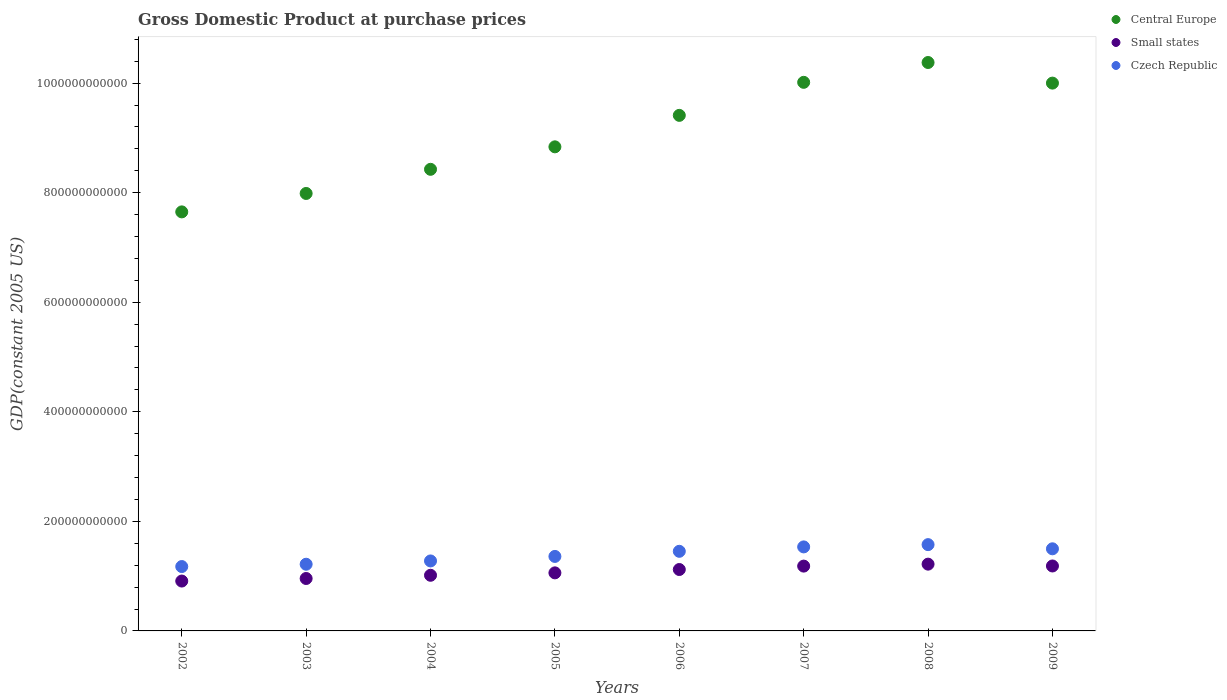How many different coloured dotlines are there?
Keep it short and to the point. 3. What is the GDP at purchase prices in Central Europe in 2002?
Your answer should be very brief. 7.65e+11. Across all years, what is the maximum GDP at purchase prices in Small states?
Offer a terse response. 1.22e+11. Across all years, what is the minimum GDP at purchase prices in Small states?
Provide a succinct answer. 9.10e+1. In which year was the GDP at purchase prices in Czech Republic maximum?
Keep it short and to the point. 2008. What is the total GDP at purchase prices in Small states in the graph?
Your response must be concise. 8.65e+11. What is the difference between the GDP at purchase prices in Small states in 2003 and that in 2006?
Provide a short and direct response. -1.64e+1. What is the difference between the GDP at purchase prices in Central Europe in 2007 and the GDP at purchase prices in Small states in 2008?
Offer a very short reply. 8.80e+11. What is the average GDP at purchase prices in Central Europe per year?
Your answer should be compact. 9.09e+11. In the year 2006, what is the difference between the GDP at purchase prices in Small states and GDP at purchase prices in Central Europe?
Ensure brevity in your answer.  -8.29e+11. What is the ratio of the GDP at purchase prices in Central Europe in 2002 to that in 2006?
Offer a terse response. 0.81. What is the difference between the highest and the second highest GDP at purchase prices in Small states?
Provide a succinct answer. 3.35e+09. What is the difference between the highest and the lowest GDP at purchase prices in Central Europe?
Offer a very short reply. 2.73e+11. In how many years, is the GDP at purchase prices in Small states greater than the average GDP at purchase prices in Small states taken over all years?
Provide a succinct answer. 4. Is the GDP at purchase prices in Small states strictly less than the GDP at purchase prices in Central Europe over the years?
Your response must be concise. Yes. How many years are there in the graph?
Provide a succinct answer. 8. What is the difference between two consecutive major ticks on the Y-axis?
Ensure brevity in your answer.  2.00e+11. Are the values on the major ticks of Y-axis written in scientific E-notation?
Make the answer very short. No. Where does the legend appear in the graph?
Keep it short and to the point. Top right. How many legend labels are there?
Give a very brief answer. 3. What is the title of the graph?
Provide a succinct answer. Gross Domestic Product at purchase prices. Does "Costa Rica" appear as one of the legend labels in the graph?
Your answer should be very brief. No. What is the label or title of the Y-axis?
Your response must be concise. GDP(constant 2005 US). What is the GDP(constant 2005 US) of Central Europe in 2002?
Your answer should be very brief. 7.65e+11. What is the GDP(constant 2005 US) of Small states in 2002?
Provide a short and direct response. 9.10e+1. What is the GDP(constant 2005 US) of Czech Republic in 2002?
Your answer should be compact. 1.18e+11. What is the GDP(constant 2005 US) in Central Europe in 2003?
Your answer should be very brief. 7.99e+11. What is the GDP(constant 2005 US) of Small states in 2003?
Ensure brevity in your answer.  9.57e+1. What is the GDP(constant 2005 US) in Czech Republic in 2003?
Your answer should be compact. 1.22e+11. What is the GDP(constant 2005 US) of Central Europe in 2004?
Give a very brief answer. 8.43e+11. What is the GDP(constant 2005 US) of Small states in 2004?
Make the answer very short. 1.02e+11. What is the GDP(constant 2005 US) in Czech Republic in 2004?
Your answer should be very brief. 1.28e+11. What is the GDP(constant 2005 US) in Central Europe in 2005?
Provide a short and direct response. 8.84e+11. What is the GDP(constant 2005 US) of Small states in 2005?
Keep it short and to the point. 1.06e+11. What is the GDP(constant 2005 US) in Czech Republic in 2005?
Keep it short and to the point. 1.36e+11. What is the GDP(constant 2005 US) of Central Europe in 2006?
Give a very brief answer. 9.41e+11. What is the GDP(constant 2005 US) of Small states in 2006?
Make the answer very short. 1.12e+11. What is the GDP(constant 2005 US) in Czech Republic in 2006?
Your answer should be compact. 1.45e+11. What is the GDP(constant 2005 US) of Central Europe in 2007?
Your answer should be very brief. 1.00e+12. What is the GDP(constant 2005 US) of Small states in 2007?
Offer a terse response. 1.18e+11. What is the GDP(constant 2005 US) in Czech Republic in 2007?
Give a very brief answer. 1.53e+11. What is the GDP(constant 2005 US) in Central Europe in 2008?
Provide a succinct answer. 1.04e+12. What is the GDP(constant 2005 US) of Small states in 2008?
Provide a succinct answer. 1.22e+11. What is the GDP(constant 2005 US) of Czech Republic in 2008?
Give a very brief answer. 1.58e+11. What is the GDP(constant 2005 US) in Central Europe in 2009?
Make the answer very short. 1.00e+12. What is the GDP(constant 2005 US) in Small states in 2009?
Your response must be concise. 1.19e+11. What is the GDP(constant 2005 US) of Czech Republic in 2009?
Keep it short and to the point. 1.50e+11. Across all years, what is the maximum GDP(constant 2005 US) in Central Europe?
Make the answer very short. 1.04e+12. Across all years, what is the maximum GDP(constant 2005 US) in Small states?
Give a very brief answer. 1.22e+11. Across all years, what is the maximum GDP(constant 2005 US) of Czech Republic?
Offer a terse response. 1.58e+11. Across all years, what is the minimum GDP(constant 2005 US) in Central Europe?
Give a very brief answer. 7.65e+11. Across all years, what is the minimum GDP(constant 2005 US) of Small states?
Provide a short and direct response. 9.10e+1. Across all years, what is the minimum GDP(constant 2005 US) of Czech Republic?
Provide a succinct answer. 1.18e+11. What is the total GDP(constant 2005 US) in Central Europe in the graph?
Your answer should be compact. 7.27e+12. What is the total GDP(constant 2005 US) in Small states in the graph?
Offer a very short reply. 8.65e+11. What is the total GDP(constant 2005 US) of Czech Republic in the graph?
Your response must be concise. 1.11e+12. What is the difference between the GDP(constant 2005 US) of Central Europe in 2002 and that in 2003?
Make the answer very short. -3.36e+1. What is the difference between the GDP(constant 2005 US) of Small states in 2002 and that in 2003?
Ensure brevity in your answer.  -4.67e+09. What is the difference between the GDP(constant 2005 US) in Czech Republic in 2002 and that in 2003?
Offer a very short reply. -4.23e+09. What is the difference between the GDP(constant 2005 US) in Central Europe in 2002 and that in 2004?
Ensure brevity in your answer.  -7.77e+1. What is the difference between the GDP(constant 2005 US) in Small states in 2002 and that in 2004?
Give a very brief answer. -1.05e+1. What is the difference between the GDP(constant 2005 US) of Czech Republic in 2002 and that in 2004?
Provide a short and direct response. -1.03e+1. What is the difference between the GDP(constant 2005 US) of Central Europe in 2002 and that in 2005?
Ensure brevity in your answer.  -1.19e+11. What is the difference between the GDP(constant 2005 US) of Small states in 2002 and that in 2005?
Your answer should be very brief. -1.49e+1. What is the difference between the GDP(constant 2005 US) of Czech Republic in 2002 and that in 2005?
Keep it short and to the point. -1.85e+1. What is the difference between the GDP(constant 2005 US) in Central Europe in 2002 and that in 2006?
Give a very brief answer. -1.76e+11. What is the difference between the GDP(constant 2005 US) in Small states in 2002 and that in 2006?
Provide a succinct answer. -2.11e+1. What is the difference between the GDP(constant 2005 US) in Czech Republic in 2002 and that in 2006?
Offer a terse response. -2.78e+1. What is the difference between the GDP(constant 2005 US) in Central Europe in 2002 and that in 2007?
Provide a succinct answer. -2.37e+11. What is the difference between the GDP(constant 2005 US) in Small states in 2002 and that in 2007?
Keep it short and to the point. -2.73e+1. What is the difference between the GDP(constant 2005 US) of Czech Republic in 2002 and that in 2007?
Your response must be concise. -3.59e+1. What is the difference between the GDP(constant 2005 US) of Central Europe in 2002 and that in 2008?
Your answer should be very brief. -2.73e+11. What is the difference between the GDP(constant 2005 US) of Small states in 2002 and that in 2008?
Provide a succinct answer. -3.09e+1. What is the difference between the GDP(constant 2005 US) of Czech Republic in 2002 and that in 2008?
Give a very brief answer. -4.00e+1. What is the difference between the GDP(constant 2005 US) in Central Europe in 2002 and that in 2009?
Give a very brief answer. -2.35e+11. What is the difference between the GDP(constant 2005 US) of Small states in 2002 and that in 2009?
Make the answer very short. -2.75e+1. What is the difference between the GDP(constant 2005 US) of Czech Republic in 2002 and that in 2009?
Keep it short and to the point. -3.24e+1. What is the difference between the GDP(constant 2005 US) in Central Europe in 2003 and that in 2004?
Keep it short and to the point. -4.41e+1. What is the difference between the GDP(constant 2005 US) of Small states in 2003 and that in 2004?
Your answer should be compact. -5.88e+09. What is the difference between the GDP(constant 2005 US) in Czech Republic in 2003 and that in 2004?
Offer a very short reply. -6.02e+09. What is the difference between the GDP(constant 2005 US) in Central Europe in 2003 and that in 2005?
Your answer should be compact. -8.51e+1. What is the difference between the GDP(constant 2005 US) of Small states in 2003 and that in 2005?
Keep it short and to the point. -1.03e+1. What is the difference between the GDP(constant 2005 US) of Czech Republic in 2003 and that in 2005?
Make the answer very short. -1.43e+1. What is the difference between the GDP(constant 2005 US) of Central Europe in 2003 and that in 2006?
Ensure brevity in your answer.  -1.43e+11. What is the difference between the GDP(constant 2005 US) in Small states in 2003 and that in 2006?
Your answer should be very brief. -1.64e+1. What is the difference between the GDP(constant 2005 US) in Czech Republic in 2003 and that in 2006?
Make the answer very short. -2.36e+1. What is the difference between the GDP(constant 2005 US) of Central Europe in 2003 and that in 2007?
Offer a terse response. -2.03e+11. What is the difference between the GDP(constant 2005 US) in Small states in 2003 and that in 2007?
Provide a succinct answer. -2.26e+1. What is the difference between the GDP(constant 2005 US) of Czech Republic in 2003 and that in 2007?
Offer a terse response. -3.16e+1. What is the difference between the GDP(constant 2005 US) in Central Europe in 2003 and that in 2008?
Give a very brief answer. -2.39e+11. What is the difference between the GDP(constant 2005 US) of Small states in 2003 and that in 2008?
Keep it short and to the point. -2.62e+1. What is the difference between the GDP(constant 2005 US) of Czech Republic in 2003 and that in 2008?
Provide a succinct answer. -3.58e+1. What is the difference between the GDP(constant 2005 US) in Central Europe in 2003 and that in 2009?
Provide a succinct answer. -2.01e+11. What is the difference between the GDP(constant 2005 US) in Small states in 2003 and that in 2009?
Provide a short and direct response. -2.28e+1. What is the difference between the GDP(constant 2005 US) of Czech Republic in 2003 and that in 2009?
Give a very brief answer. -2.82e+1. What is the difference between the GDP(constant 2005 US) of Central Europe in 2004 and that in 2005?
Keep it short and to the point. -4.10e+1. What is the difference between the GDP(constant 2005 US) in Small states in 2004 and that in 2005?
Make the answer very short. -4.40e+09. What is the difference between the GDP(constant 2005 US) of Czech Republic in 2004 and that in 2005?
Give a very brief answer. -8.23e+09. What is the difference between the GDP(constant 2005 US) in Central Europe in 2004 and that in 2006?
Provide a short and direct response. -9.85e+1. What is the difference between the GDP(constant 2005 US) in Small states in 2004 and that in 2006?
Your answer should be compact. -1.05e+1. What is the difference between the GDP(constant 2005 US) of Czech Republic in 2004 and that in 2006?
Keep it short and to the point. -1.76e+1. What is the difference between the GDP(constant 2005 US) of Central Europe in 2004 and that in 2007?
Your answer should be compact. -1.59e+11. What is the difference between the GDP(constant 2005 US) in Small states in 2004 and that in 2007?
Your answer should be compact. -1.67e+1. What is the difference between the GDP(constant 2005 US) of Czech Republic in 2004 and that in 2007?
Your answer should be compact. -2.56e+1. What is the difference between the GDP(constant 2005 US) of Central Europe in 2004 and that in 2008?
Your response must be concise. -1.95e+11. What is the difference between the GDP(constant 2005 US) of Small states in 2004 and that in 2008?
Your answer should be compact. -2.03e+1. What is the difference between the GDP(constant 2005 US) of Czech Republic in 2004 and that in 2008?
Offer a very short reply. -2.98e+1. What is the difference between the GDP(constant 2005 US) in Central Europe in 2004 and that in 2009?
Make the answer very short. -1.57e+11. What is the difference between the GDP(constant 2005 US) of Small states in 2004 and that in 2009?
Ensure brevity in your answer.  -1.70e+1. What is the difference between the GDP(constant 2005 US) of Czech Republic in 2004 and that in 2009?
Provide a short and direct response. -2.21e+1. What is the difference between the GDP(constant 2005 US) in Central Europe in 2005 and that in 2006?
Ensure brevity in your answer.  -5.74e+1. What is the difference between the GDP(constant 2005 US) in Small states in 2005 and that in 2006?
Your answer should be very brief. -6.12e+09. What is the difference between the GDP(constant 2005 US) in Czech Republic in 2005 and that in 2006?
Make the answer very short. -9.35e+09. What is the difference between the GDP(constant 2005 US) in Central Europe in 2005 and that in 2007?
Provide a succinct answer. -1.18e+11. What is the difference between the GDP(constant 2005 US) of Small states in 2005 and that in 2007?
Ensure brevity in your answer.  -1.23e+1. What is the difference between the GDP(constant 2005 US) of Czech Republic in 2005 and that in 2007?
Offer a terse response. -1.74e+1. What is the difference between the GDP(constant 2005 US) in Central Europe in 2005 and that in 2008?
Give a very brief answer. -1.54e+11. What is the difference between the GDP(constant 2005 US) in Small states in 2005 and that in 2008?
Your response must be concise. -1.59e+1. What is the difference between the GDP(constant 2005 US) of Czech Republic in 2005 and that in 2008?
Offer a terse response. -2.15e+1. What is the difference between the GDP(constant 2005 US) in Central Europe in 2005 and that in 2009?
Provide a short and direct response. -1.16e+11. What is the difference between the GDP(constant 2005 US) of Small states in 2005 and that in 2009?
Provide a succinct answer. -1.26e+1. What is the difference between the GDP(constant 2005 US) in Czech Republic in 2005 and that in 2009?
Your answer should be very brief. -1.39e+1. What is the difference between the GDP(constant 2005 US) in Central Europe in 2006 and that in 2007?
Offer a terse response. -6.03e+1. What is the difference between the GDP(constant 2005 US) in Small states in 2006 and that in 2007?
Your answer should be compact. -6.22e+09. What is the difference between the GDP(constant 2005 US) of Czech Republic in 2006 and that in 2007?
Make the answer very short. -8.04e+09. What is the difference between the GDP(constant 2005 US) of Central Europe in 2006 and that in 2008?
Offer a very short reply. -9.65e+1. What is the difference between the GDP(constant 2005 US) of Small states in 2006 and that in 2008?
Provide a short and direct response. -9.80e+09. What is the difference between the GDP(constant 2005 US) of Czech Republic in 2006 and that in 2008?
Your answer should be compact. -1.22e+1. What is the difference between the GDP(constant 2005 US) of Central Europe in 2006 and that in 2009?
Offer a terse response. -5.89e+1. What is the difference between the GDP(constant 2005 US) in Small states in 2006 and that in 2009?
Offer a terse response. -6.45e+09. What is the difference between the GDP(constant 2005 US) in Czech Republic in 2006 and that in 2009?
Make the answer very short. -4.57e+09. What is the difference between the GDP(constant 2005 US) in Central Europe in 2007 and that in 2008?
Offer a very short reply. -3.62e+1. What is the difference between the GDP(constant 2005 US) of Small states in 2007 and that in 2008?
Keep it short and to the point. -3.59e+09. What is the difference between the GDP(constant 2005 US) in Czech Republic in 2007 and that in 2008?
Keep it short and to the point. -4.16e+09. What is the difference between the GDP(constant 2005 US) of Central Europe in 2007 and that in 2009?
Ensure brevity in your answer.  1.42e+09. What is the difference between the GDP(constant 2005 US) of Small states in 2007 and that in 2009?
Ensure brevity in your answer.  -2.36e+08. What is the difference between the GDP(constant 2005 US) in Czech Republic in 2007 and that in 2009?
Your response must be concise. 3.47e+09. What is the difference between the GDP(constant 2005 US) of Central Europe in 2008 and that in 2009?
Your response must be concise. 3.76e+1. What is the difference between the GDP(constant 2005 US) in Small states in 2008 and that in 2009?
Keep it short and to the point. 3.35e+09. What is the difference between the GDP(constant 2005 US) of Czech Republic in 2008 and that in 2009?
Your answer should be compact. 7.63e+09. What is the difference between the GDP(constant 2005 US) in Central Europe in 2002 and the GDP(constant 2005 US) in Small states in 2003?
Make the answer very short. 6.69e+11. What is the difference between the GDP(constant 2005 US) of Central Europe in 2002 and the GDP(constant 2005 US) of Czech Republic in 2003?
Provide a succinct answer. 6.43e+11. What is the difference between the GDP(constant 2005 US) in Small states in 2002 and the GDP(constant 2005 US) in Czech Republic in 2003?
Keep it short and to the point. -3.07e+1. What is the difference between the GDP(constant 2005 US) of Central Europe in 2002 and the GDP(constant 2005 US) of Small states in 2004?
Give a very brief answer. 6.63e+11. What is the difference between the GDP(constant 2005 US) of Central Europe in 2002 and the GDP(constant 2005 US) of Czech Republic in 2004?
Provide a short and direct response. 6.37e+11. What is the difference between the GDP(constant 2005 US) in Small states in 2002 and the GDP(constant 2005 US) in Czech Republic in 2004?
Keep it short and to the point. -3.67e+1. What is the difference between the GDP(constant 2005 US) of Central Europe in 2002 and the GDP(constant 2005 US) of Small states in 2005?
Your answer should be very brief. 6.59e+11. What is the difference between the GDP(constant 2005 US) of Central Europe in 2002 and the GDP(constant 2005 US) of Czech Republic in 2005?
Ensure brevity in your answer.  6.29e+11. What is the difference between the GDP(constant 2005 US) in Small states in 2002 and the GDP(constant 2005 US) in Czech Republic in 2005?
Provide a short and direct response. -4.50e+1. What is the difference between the GDP(constant 2005 US) of Central Europe in 2002 and the GDP(constant 2005 US) of Small states in 2006?
Your answer should be compact. 6.53e+11. What is the difference between the GDP(constant 2005 US) in Central Europe in 2002 and the GDP(constant 2005 US) in Czech Republic in 2006?
Your answer should be compact. 6.20e+11. What is the difference between the GDP(constant 2005 US) in Small states in 2002 and the GDP(constant 2005 US) in Czech Republic in 2006?
Keep it short and to the point. -5.43e+1. What is the difference between the GDP(constant 2005 US) of Central Europe in 2002 and the GDP(constant 2005 US) of Small states in 2007?
Ensure brevity in your answer.  6.47e+11. What is the difference between the GDP(constant 2005 US) in Central Europe in 2002 and the GDP(constant 2005 US) in Czech Republic in 2007?
Ensure brevity in your answer.  6.12e+11. What is the difference between the GDP(constant 2005 US) of Small states in 2002 and the GDP(constant 2005 US) of Czech Republic in 2007?
Offer a terse response. -6.23e+1. What is the difference between the GDP(constant 2005 US) of Central Europe in 2002 and the GDP(constant 2005 US) of Small states in 2008?
Keep it short and to the point. 6.43e+11. What is the difference between the GDP(constant 2005 US) in Central Europe in 2002 and the GDP(constant 2005 US) in Czech Republic in 2008?
Give a very brief answer. 6.07e+11. What is the difference between the GDP(constant 2005 US) of Small states in 2002 and the GDP(constant 2005 US) of Czech Republic in 2008?
Provide a succinct answer. -6.65e+1. What is the difference between the GDP(constant 2005 US) in Central Europe in 2002 and the GDP(constant 2005 US) in Small states in 2009?
Offer a very short reply. 6.46e+11. What is the difference between the GDP(constant 2005 US) in Central Europe in 2002 and the GDP(constant 2005 US) in Czech Republic in 2009?
Offer a very short reply. 6.15e+11. What is the difference between the GDP(constant 2005 US) of Small states in 2002 and the GDP(constant 2005 US) of Czech Republic in 2009?
Give a very brief answer. -5.89e+1. What is the difference between the GDP(constant 2005 US) in Central Europe in 2003 and the GDP(constant 2005 US) in Small states in 2004?
Provide a short and direct response. 6.97e+11. What is the difference between the GDP(constant 2005 US) in Central Europe in 2003 and the GDP(constant 2005 US) in Czech Republic in 2004?
Offer a very short reply. 6.71e+11. What is the difference between the GDP(constant 2005 US) in Small states in 2003 and the GDP(constant 2005 US) in Czech Republic in 2004?
Offer a very short reply. -3.21e+1. What is the difference between the GDP(constant 2005 US) in Central Europe in 2003 and the GDP(constant 2005 US) in Small states in 2005?
Ensure brevity in your answer.  6.93e+11. What is the difference between the GDP(constant 2005 US) of Central Europe in 2003 and the GDP(constant 2005 US) of Czech Republic in 2005?
Provide a short and direct response. 6.63e+11. What is the difference between the GDP(constant 2005 US) in Small states in 2003 and the GDP(constant 2005 US) in Czech Republic in 2005?
Give a very brief answer. -4.03e+1. What is the difference between the GDP(constant 2005 US) of Central Europe in 2003 and the GDP(constant 2005 US) of Small states in 2006?
Your answer should be compact. 6.87e+11. What is the difference between the GDP(constant 2005 US) in Central Europe in 2003 and the GDP(constant 2005 US) in Czech Republic in 2006?
Make the answer very short. 6.53e+11. What is the difference between the GDP(constant 2005 US) of Small states in 2003 and the GDP(constant 2005 US) of Czech Republic in 2006?
Make the answer very short. -4.96e+1. What is the difference between the GDP(constant 2005 US) in Central Europe in 2003 and the GDP(constant 2005 US) in Small states in 2007?
Your response must be concise. 6.80e+11. What is the difference between the GDP(constant 2005 US) in Central Europe in 2003 and the GDP(constant 2005 US) in Czech Republic in 2007?
Your response must be concise. 6.45e+11. What is the difference between the GDP(constant 2005 US) of Small states in 2003 and the GDP(constant 2005 US) of Czech Republic in 2007?
Your answer should be compact. -5.77e+1. What is the difference between the GDP(constant 2005 US) in Central Europe in 2003 and the GDP(constant 2005 US) in Small states in 2008?
Your answer should be very brief. 6.77e+11. What is the difference between the GDP(constant 2005 US) in Central Europe in 2003 and the GDP(constant 2005 US) in Czech Republic in 2008?
Keep it short and to the point. 6.41e+11. What is the difference between the GDP(constant 2005 US) of Small states in 2003 and the GDP(constant 2005 US) of Czech Republic in 2008?
Keep it short and to the point. -6.18e+1. What is the difference between the GDP(constant 2005 US) of Central Europe in 2003 and the GDP(constant 2005 US) of Small states in 2009?
Give a very brief answer. 6.80e+11. What is the difference between the GDP(constant 2005 US) of Central Europe in 2003 and the GDP(constant 2005 US) of Czech Republic in 2009?
Offer a very short reply. 6.49e+11. What is the difference between the GDP(constant 2005 US) of Small states in 2003 and the GDP(constant 2005 US) of Czech Republic in 2009?
Provide a short and direct response. -5.42e+1. What is the difference between the GDP(constant 2005 US) in Central Europe in 2004 and the GDP(constant 2005 US) in Small states in 2005?
Your answer should be compact. 7.37e+11. What is the difference between the GDP(constant 2005 US) in Central Europe in 2004 and the GDP(constant 2005 US) in Czech Republic in 2005?
Your answer should be compact. 7.07e+11. What is the difference between the GDP(constant 2005 US) in Small states in 2004 and the GDP(constant 2005 US) in Czech Republic in 2005?
Ensure brevity in your answer.  -3.44e+1. What is the difference between the GDP(constant 2005 US) of Central Europe in 2004 and the GDP(constant 2005 US) of Small states in 2006?
Offer a very short reply. 7.31e+11. What is the difference between the GDP(constant 2005 US) of Central Europe in 2004 and the GDP(constant 2005 US) of Czech Republic in 2006?
Your answer should be compact. 6.97e+11. What is the difference between the GDP(constant 2005 US) of Small states in 2004 and the GDP(constant 2005 US) of Czech Republic in 2006?
Make the answer very short. -4.38e+1. What is the difference between the GDP(constant 2005 US) in Central Europe in 2004 and the GDP(constant 2005 US) in Small states in 2007?
Offer a terse response. 7.24e+11. What is the difference between the GDP(constant 2005 US) in Central Europe in 2004 and the GDP(constant 2005 US) in Czech Republic in 2007?
Ensure brevity in your answer.  6.89e+11. What is the difference between the GDP(constant 2005 US) in Small states in 2004 and the GDP(constant 2005 US) in Czech Republic in 2007?
Provide a succinct answer. -5.18e+1. What is the difference between the GDP(constant 2005 US) in Central Europe in 2004 and the GDP(constant 2005 US) in Small states in 2008?
Provide a succinct answer. 7.21e+11. What is the difference between the GDP(constant 2005 US) of Central Europe in 2004 and the GDP(constant 2005 US) of Czech Republic in 2008?
Ensure brevity in your answer.  6.85e+11. What is the difference between the GDP(constant 2005 US) in Small states in 2004 and the GDP(constant 2005 US) in Czech Republic in 2008?
Your response must be concise. -5.60e+1. What is the difference between the GDP(constant 2005 US) in Central Europe in 2004 and the GDP(constant 2005 US) in Small states in 2009?
Ensure brevity in your answer.  7.24e+11. What is the difference between the GDP(constant 2005 US) of Central Europe in 2004 and the GDP(constant 2005 US) of Czech Republic in 2009?
Offer a terse response. 6.93e+11. What is the difference between the GDP(constant 2005 US) in Small states in 2004 and the GDP(constant 2005 US) in Czech Republic in 2009?
Your answer should be compact. -4.83e+1. What is the difference between the GDP(constant 2005 US) in Central Europe in 2005 and the GDP(constant 2005 US) in Small states in 2006?
Your response must be concise. 7.72e+11. What is the difference between the GDP(constant 2005 US) of Central Europe in 2005 and the GDP(constant 2005 US) of Czech Republic in 2006?
Offer a terse response. 7.38e+11. What is the difference between the GDP(constant 2005 US) in Small states in 2005 and the GDP(constant 2005 US) in Czech Republic in 2006?
Make the answer very short. -3.94e+1. What is the difference between the GDP(constant 2005 US) of Central Europe in 2005 and the GDP(constant 2005 US) of Small states in 2007?
Provide a succinct answer. 7.65e+11. What is the difference between the GDP(constant 2005 US) in Central Europe in 2005 and the GDP(constant 2005 US) in Czech Republic in 2007?
Give a very brief answer. 7.30e+11. What is the difference between the GDP(constant 2005 US) in Small states in 2005 and the GDP(constant 2005 US) in Czech Republic in 2007?
Keep it short and to the point. -4.74e+1. What is the difference between the GDP(constant 2005 US) in Central Europe in 2005 and the GDP(constant 2005 US) in Small states in 2008?
Your response must be concise. 7.62e+11. What is the difference between the GDP(constant 2005 US) of Central Europe in 2005 and the GDP(constant 2005 US) of Czech Republic in 2008?
Your answer should be compact. 7.26e+11. What is the difference between the GDP(constant 2005 US) in Small states in 2005 and the GDP(constant 2005 US) in Czech Republic in 2008?
Your answer should be very brief. -5.16e+1. What is the difference between the GDP(constant 2005 US) of Central Europe in 2005 and the GDP(constant 2005 US) of Small states in 2009?
Your answer should be very brief. 7.65e+11. What is the difference between the GDP(constant 2005 US) in Central Europe in 2005 and the GDP(constant 2005 US) in Czech Republic in 2009?
Give a very brief answer. 7.34e+11. What is the difference between the GDP(constant 2005 US) in Small states in 2005 and the GDP(constant 2005 US) in Czech Republic in 2009?
Your answer should be very brief. -4.39e+1. What is the difference between the GDP(constant 2005 US) in Central Europe in 2006 and the GDP(constant 2005 US) in Small states in 2007?
Give a very brief answer. 8.23e+11. What is the difference between the GDP(constant 2005 US) in Central Europe in 2006 and the GDP(constant 2005 US) in Czech Republic in 2007?
Keep it short and to the point. 7.88e+11. What is the difference between the GDP(constant 2005 US) of Small states in 2006 and the GDP(constant 2005 US) of Czech Republic in 2007?
Make the answer very short. -4.13e+1. What is the difference between the GDP(constant 2005 US) in Central Europe in 2006 and the GDP(constant 2005 US) in Small states in 2008?
Make the answer very short. 8.19e+11. What is the difference between the GDP(constant 2005 US) in Central Europe in 2006 and the GDP(constant 2005 US) in Czech Republic in 2008?
Keep it short and to the point. 7.84e+11. What is the difference between the GDP(constant 2005 US) of Small states in 2006 and the GDP(constant 2005 US) of Czech Republic in 2008?
Offer a very short reply. -4.54e+1. What is the difference between the GDP(constant 2005 US) of Central Europe in 2006 and the GDP(constant 2005 US) of Small states in 2009?
Your response must be concise. 8.23e+11. What is the difference between the GDP(constant 2005 US) of Central Europe in 2006 and the GDP(constant 2005 US) of Czech Republic in 2009?
Offer a terse response. 7.91e+11. What is the difference between the GDP(constant 2005 US) of Small states in 2006 and the GDP(constant 2005 US) of Czech Republic in 2009?
Give a very brief answer. -3.78e+1. What is the difference between the GDP(constant 2005 US) of Central Europe in 2007 and the GDP(constant 2005 US) of Small states in 2008?
Keep it short and to the point. 8.80e+11. What is the difference between the GDP(constant 2005 US) in Central Europe in 2007 and the GDP(constant 2005 US) in Czech Republic in 2008?
Your answer should be very brief. 8.44e+11. What is the difference between the GDP(constant 2005 US) in Small states in 2007 and the GDP(constant 2005 US) in Czech Republic in 2008?
Your answer should be very brief. -3.92e+1. What is the difference between the GDP(constant 2005 US) in Central Europe in 2007 and the GDP(constant 2005 US) in Small states in 2009?
Ensure brevity in your answer.  8.83e+11. What is the difference between the GDP(constant 2005 US) of Central Europe in 2007 and the GDP(constant 2005 US) of Czech Republic in 2009?
Offer a very short reply. 8.52e+11. What is the difference between the GDP(constant 2005 US) in Small states in 2007 and the GDP(constant 2005 US) in Czech Republic in 2009?
Give a very brief answer. -3.16e+1. What is the difference between the GDP(constant 2005 US) of Central Europe in 2008 and the GDP(constant 2005 US) of Small states in 2009?
Give a very brief answer. 9.19e+11. What is the difference between the GDP(constant 2005 US) in Central Europe in 2008 and the GDP(constant 2005 US) in Czech Republic in 2009?
Your answer should be very brief. 8.88e+11. What is the difference between the GDP(constant 2005 US) in Small states in 2008 and the GDP(constant 2005 US) in Czech Republic in 2009?
Provide a short and direct response. -2.80e+1. What is the average GDP(constant 2005 US) of Central Europe per year?
Ensure brevity in your answer.  9.09e+11. What is the average GDP(constant 2005 US) in Small states per year?
Your response must be concise. 1.08e+11. What is the average GDP(constant 2005 US) in Czech Republic per year?
Your answer should be compact. 1.39e+11. In the year 2002, what is the difference between the GDP(constant 2005 US) in Central Europe and GDP(constant 2005 US) in Small states?
Provide a short and direct response. 6.74e+11. In the year 2002, what is the difference between the GDP(constant 2005 US) in Central Europe and GDP(constant 2005 US) in Czech Republic?
Your answer should be compact. 6.47e+11. In the year 2002, what is the difference between the GDP(constant 2005 US) of Small states and GDP(constant 2005 US) of Czech Republic?
Provide a succinct answer. -2.65e+1. In the year 2003, what is the difference between the GDP(constant 2005 US) of Central Europe and GDP(constant 2005 US) of Small states?
Offer a very short reply. 7.03e+11. In the year 2003, what is the difference between the GDP(constant 2005 US) of Central Europe and GDP(constant 2005 US) of Czech Republic?
Keep it short and to the point. 6.77e+11. In the year 2003, what is the difference between the GDP(constant 2005 US) in Small states and GDP(constant 2005 US) in Czech Republic?
Provide a succinct answer. -2.60e+1. In the year 2004, what is the difference between the GDP(constant 2005 US) in Central Europe and GDP(constant 2005 US) in Small states?
Keep it short and to the point. 7.41e+11. In the year 2004, what is the difference between the GDP(constant 2005 US) of Central Europe and GDP(constant 2005 US) of Czech Republic?
Offer a terse response. 7.15e+11. In the year 2004, what is the difference between the GDP(constant 2005 US) in Small states and GDP(constant 2005 US) in Czech Republic?
Keep it short and to the point. -2.62e+1. In the year 2005, what is the difference between the GDP(constant 2005 US) in Central Europe and GDP(constant 2005 US) in Small states?
Offer a very short reply. 7.78e+11. In the year 2005, what is the difference between the GDP(constant 2005 US) of Central Europe and GDP(constant 2005 US) of Czech Republic?
Your answer should be compact. 7.48e+11. In the year 2005, what is the difference between the GDP(constant 2005 US) in Small states and GDP(constant 2005 US) in Czech Republic?
Give a very brief answer. -3.00e+1. In the year 2006, what is the difference between the GDP(constant 2005 US) in Central Europe and GDP(constant 2005 US) in Small states?
Offer a terse response. 8.29e+11. In the year 2006, what is the difference between the GDP(constant 2005 US) of Central Europe and GDP(constant 2005 US) of Czech Republic?
Your answer should be very brief. 7.96e+11. In the year 2006, what is the difference between the GDP(constant 2005 US) in Small states and GDP(constant 2005 US) in Czech Republic?
Provide a short and direct response. -3.32e+1. In the year 2007, what is the difference between the GDP(constant 2005 US) of Central Europe and GDP(constant 2005 US) of Small states?
Provide a short and direct response. 8.83e+11. In the year 2007, what is the difference between the GDP(constant 2005 US) in Central Europe and GDP(constant 2005 US) in Czech Republic?
Make the answer very short. 8.48e+11. In the year 2007, what is the difference between the GDP(constant 2005 US) in Small states and GDP(constant 2005 US) in Czech Republic?
Provide a succinct answer. -3.51e+1. In the year 2008, what is the difference between the GDP(constant 2005 US) in Central Europe and GDP(constant 2005 US) in Small states?
Offer a terse response. 9.16e+11. In the year 2008, what is the difference between the GDP(constant 2005 US) of Central Europe and GDP(constant 2005 US) of Czech Republic?
Your answer should be compact. 8.80e+11. In the year 2008, what is the difference between the GDP(constant 2005 US) in Small states and GDP(constant 2005 US) in Czech Republic?
Give a very brief answer. -3.56e+1. In the year 2009, what is the difference between the GDP(constant 2005 US) in Central Europe and GDP(constant 2005 US) in Small states?
Your answer should be compact. 8.82e+11. In the year 2009, what is the difference between the GDP(constant 2005 US) of Central Europe and GDP(constant 2005 US) of Czech Republic?
Your response must be concise. 8.50e+11. In the year 2009, what is the difference between the GDP(constant 2005 US) of Small states and GDP(constant 2005 US) of Czech Republic?
Offer a very short reply. -3.14e+1. What is the ratio of the GDP(constant 2005 US) of Central Europe in 2002 to that in 2003?
Provide a succinct answer. 0.96. What is the ratio of the GDP(constant 2005 US) in Small states in 2002 to that in 2003?
Offer a terse response. 0.95. What is the ratio of the GDP(constant 2005 US) in Czech Republic in 2002 to that in 2003?
Offer a very short reply. 0.97. What is the ratio of the GDP(constant 2005 US) in Central Europe in 2002 to that in 2004?
Ensure brevity in your answer.  0.91. What is the ratio of the GDP(constant 2005 US) of Small states in 2002 to that in 2004?
Keep it short and to the point. 0.9. What is the ratio of the GDP(constant 2005 US) in Czech Republic in 2002 to that in 2004?
Make the answer very short. 0.92. What is the ratio of the GDP(constant 2005 US) in Central Europe in 2002 to that in 2005?
Offer a very short reply. 0.87. What is the ratio of the GDP(constant 2005 US) in Small states in 2002 to that in 2005?
Offer a terse response. 0.86. What is the ratio of the GDP(constant 2005 US) of Czech Republic in 2002 to that in 2005?
Provide a succinct answer. 0.86. What is the ratio of the GDP(constant 2005 US) in Central Europe in 2002 to that in 2006?
Your response must be concise. 0.81. What is the ratio of the GDP(constant 2005 US) in Small states in 2002 to that in 2006?
Provide a short and direct response. 0.81. What is the ratio of the GDP(constant 2005 US) of Czech Republic in 2002 to that in 2006?
Keep it short and to the point. 0.81. What is the ratio of the GDP(constant 2005 US) in Central Europe in 2002 to that in 2007?
Offer a very short reply. 0.76. What is the ratio of the GDP(constant 2005 US) of Small states in 2002 to that in 2007?
Give a very brief answer. 0.77. What is the ratio of the GDP(constant 2005 US) of Czech Republic in 2002 to that in 2007?
Offer a very short reply. 0.77. What is the ratio of the GDP(constant 2005 US) of Central Europe in 2002 to that in 2008?
Your answer should be very brief. 0.74. What is the ratio of the GDP(constant 2005 US) of Small states in 2002 to that in 2008?
Make the answer very short. 0.75. What is the ratio of the GDP(constant 2005 US) of Czech Republic in 2002 to that in 2008?
Offer a terse response. 0.75. What is the ratio of the GDP(constant 2005 US) in Central Europe in 2002 to that in 2009?
Ensure brevity in your answer.  0.76. What is the ratio of the GDP(constant 2005 US) of Small states in 2002 to that in 2009?
Your answer should be compact. 0.77. What is the ratio of the GDP(constant 2005 US) in Czech Republic in 2002 to that in 2009?
Your answer should be very brief. 0.78. What is the ratio of the GDP(constant 2005 US) of Central Europe in 2003 to that in 2004?
Your response must be concise. 0.95. What is the ratio of the GDP(constant 2005 US) of Small states in 2003 to that in 2004?
Provide a succinct answer. 0.94. What is the ratio of the GDP(constant 2005 US) in Czech Republic in 2003 to that in 2004?
Provide a short and direct response. 0.95. What is the ratio of the GDP(constant 2005 US) of Central Europe in 2003 to that in 2005?
Give a very brief answer. 0.9. What is the ratio of the GDP(constant 2005 US) of Small states in 2003 to that in 2005?
Offer a very short reply. 0.9. What is the ratio of the GDP(constant 2005 US) of Czech Republic in 2003 to that in 2005?
Make the answer very short. 0.9. What is the ratio of the GDP(constant 2005 US) in Central Europe in 2003 to that in 2006?
Your answer should be compact. 0.85. What is the ratio of the GDP(constant 2005 US) in Small states in 2003 to that in 2006?
Give a very brief answer. 0.85. What is the ratio of the GDP(constant 2005 US) in Czech Republic in 2003 to that in 2006?
Give a very brief answer. 0.84. What is the ratio of the GDP(constant 2005 US) in Central Europe in 2003 to that in 2007?
Offer a very short reply. 0.8. What is the ratio of the GDP(constant 2005 US) of Small states in 2003 to that in 2007?
Make the answer very short. 0.81. What is the ratio of the GDP(constant 2005 US) in Czech Republic in 2003 to that in 2007?
Make the answer very short. 0.79. What is the ratio of the GDP(constant 2005 US) of Central Europe in 2003 to that in 2008?
Your answer should be very brief. 0.77. What is the ratio of the GDP(constant 2005 US) of Small states in 2003 to that in 2008?
Give a very brief answer. 0.79. What is the ratio of the GDP(constant 2005 US) of Czech Republic in 2003 to that in 2008?
Offer a terse response. 0.77. What is the ratio of the GDP(constant 2005 US) in Central Europe in 2003 to that in 2009?
Give a very brief answer. 0.8. What is the ratio of the GDP(constant 2005 US) of Small states in 2003 to that in 2009?
Make the answer very short. 0.81. What is the ratio of the GDP(constant 2005 US) in Czech Republic in 2003 to that in 2009?
Your answer should be very brief. 0.81. What is the ratio of the GDP(constant 2005 US) in Central Europe in 2004 to that in 2005?
Offer a terse response. 0.95. What is the ratio of the GDP(constant 2005 US) in Small states in 2004 to that in 2005?
Provide a succinct answer. 0.96. What is the ratio of the GDP(constant 2005 US) in Czech Republic in 2004 to that in 2005?
Provide a succinct answer. 0.94. What is the ratio of the GDP(constant 2005 US) of Central Europe in 2004 to that in 2006?
Your answer should be compact. 0.9. What is the ratio of the GDP(constant 2005 US) in Small states in 2004 to that in 2006?
Offer a very short reply. 0.91. What is the ratio of the GDP(constant 2005 US) in Czech Republic in 2004 to that in 2006?
Your response must be concise. 0.88. What is the ratio of the GDP(constant 2005 US) in Central Europe in 2004 to that in 2007?
Your answer should be compact. 0.84. What is the ratio of the GDP(constant 2005 US) of Small states in 2004 to that in 2007?
Ensure brevity in your answer.  0.86. What is the ratio of the GDP(constant 2005 US) in Czech Republic in 2004 to that in 2007?
Make the answer very short. 0.83. What is the ratio of the GDP(constant 2005 US) of Central Europe in 2004 to that in 2008?
Ensure brevity in your answer.  0.81. What is the ratio of the GDP(constant 2005 US) of Czech Republic in 2004 to that in 2008?
Provide a succinct answer. 0.81. What is the ratio of the GDP(constant 2005 US) of Central Europe in 2004 to that in 2009?
Provide a short and direct response. 0.84. What is the ratio of the GDP(constant 2005 US) in Small states in 2004 to that in 2009?
Give a very brief answer. 0.86. What is the ratio of the GDP(constant 2005 US) in Czech Republic in 2004 to that in 2009?
Provide a short and direct response. 0.85. What is the ratio of the GDP(constant 2005 US) in Central Europe in 2005 to that in 2006?
Make the answer very short. 0.94. What is the ratio of the GDP(constant 2005 US) of Small states in 2005 to that in 2006?
Offer a very short reply. 0.95. What is the ratio of the GDP(constant 2005 US) in Czech Republic in 2005 to that in 2006?
Make the answer very short. 0.94. What is the ratio of the GDP(constant 2005 US) of Central Europe in 2005 to that in 2007?
Your answer should be very brief. 0.88. What is the ratio of the GDP(constant 2005 US) in Small states in 2005 to that in 2007?
Your answer should be compact. 0.9. What is the ratio of the GDP(constant 2005 US) in Czech Republic in 2005 to that in 2007?
Your response must be concise. 0.89. What is the ratio of the GDP(constant 2005 US) of Central Europe in 2005 to that in 2008?
Provide a short and direct response. 0.85. What is the ratio of the GDP(constant 2005 US) in Small states in 2005 to that in 2008?
Your response must be concise. 0.87. What is the ratio of the GDP(constant 2005 US) of Czech Republic in 2005 to that in 2008?
Provide a short and direct response. 0.86. What is the ratio of the GDP(constant 2005 US) in Central Europe in 2005 to that in 2009?
Make the answer very short. 0.88. What is the ratio of the GDP(constant 2005 US) in Small states in 2005 to that in 2009?
Give a very brief answer. 0.89. What is the ratio of the GDP(constant 2005 US) of Czech Republic in 2005 to that in 2009?
Your answer should be compact. 0.91. What is the ratio of the GDP(constant 2005 US) of Central Europe in 2006 to that in 2007?
Offer a terse response. 0.94. What is the ratio of the GDP(constant 2005 US) of Small states in 2006 to that in 2007?
Offer a very short reply. 0.95. What is the ratio of the GDP(constant 2005 US) in Czech Republic in 2006 to that in 2007?
Provide a short and direct response. 0.95. What is the ratio of the GDP(constant 2005 US) in Central Europe in 2006 to that in 2008?
Offer a terse response. 0.91. What is the ratio of the GDP(constant 2005 US) of Small states in 2006 to that in 2008?
Give a very brief answer. 0.92. What is the ratio of the GDP(constant 2005 US) in Czech Republic in 2006 to that in 2008?
Your answer should be very brief. 0.92. What is the ratio of the GDP(constant 2005 US) of Central Europe in 2006 to that in 2009?
Provide a short and direct response. 0.94. What is the ratio of the GDP(constant 2005 US) in Small states in 2006 to that in 2009?
Your response must be concise. 0.95. What is the ratio of the GDP(constant 2005 US) of Czech Republic in 2006 to that in 2009?
Offer a terse response. 0.97. What is the ratio of the GDP(constant 2005 US) of Central Europe in 2007 to that in 2008?
Ensure brevity in your answer.  0.97. What is the ratio of the GDP(constant 2005 US) of Small states in 2007 to that in 2008?
Offer a terse response. 0.97. What is the ratio of the GDP(constant 2005 US) in Czech Republic in 2007 to that in 2008?
Ensure brevity in your answer.  0.97. What is the ratio of the GDP(constant 2005 US) in Small states in 2007 to that in 2009?
Offer a terse response. 1. What is the ratio of the GDP(constant 2005 US) in Czech Republic in 2007 to that in 2009?
Keep it short and to the point. 1.02. What is the ratio of the GDP(constant 2005 US) in Central Europe in 2008 to that in 2009?
Offer a terse response. 1.04. What is the ratio of the GDP(constant 2005 US) of Small states in 2008 to that in 2009?
Make the answer very short. 1.03. What is the ratio of the GDP(constant 2005 US) in Czech Republic in 2008 to that in 2009?
Your answer should be very brief. 1.05. What is the difference between the highest and the second highest GDP(constant 2005 US) in Central Europe?
Your response must be concise. 3.62e+1. What is the difference between the highest and the second highest GDP(constant 2005 US) of Small states?
Your response must be concise. 3.35e+09. What is the difference between the highest and the second highest GDP(constant 2005 US) in Czech Republic?
Provide a short and direct response. 4.16e+09. What is the difference between the highest and the lowest GDP(constant 2005 US) of Central Europe?
Your answer should be very brief. 2.73e+11. What is the difference between the highest and the lowest GDP(constant 2005 US) of Small states?
Your answer should be very brief. 3.09e+1. What is the difference between the highest and the lowest GDP(constant 2005 US) in Czech Republic?
Make the answer very short. 4.00e+1. 